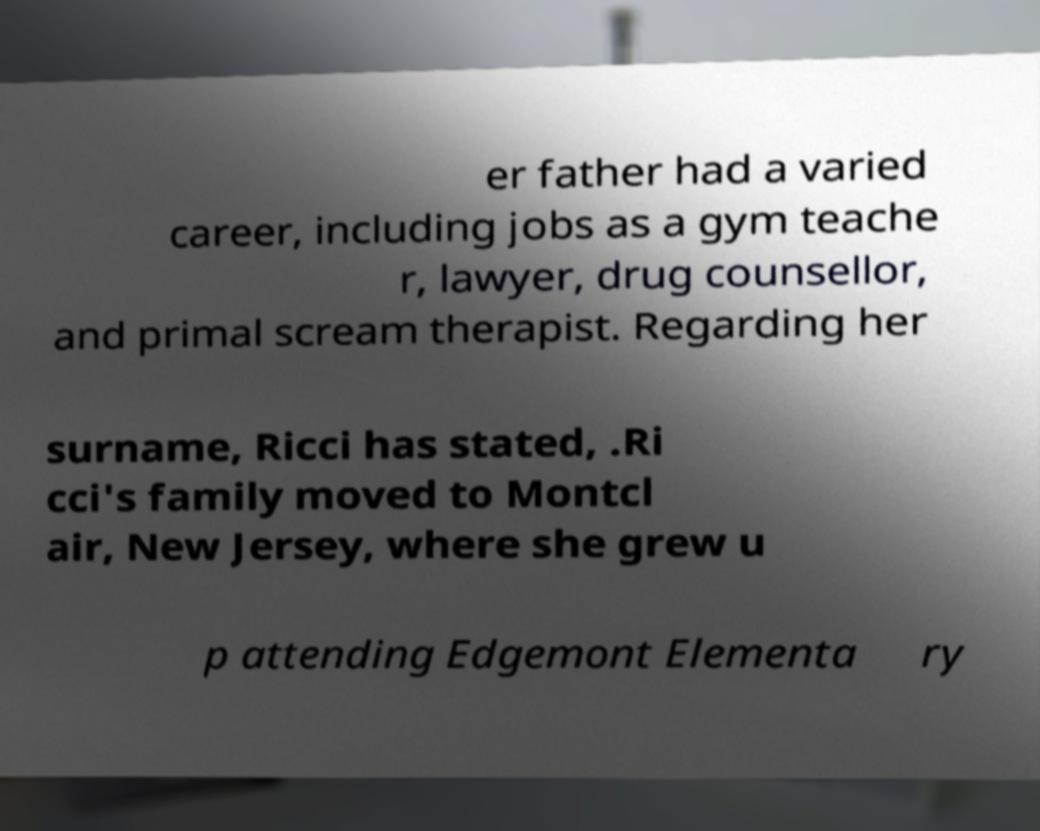I need the written content from this picture converted into text. Can you do that? er father had a varied career, including jobs as a gym teache r, lawyer, drug counsellor, and primal scream therapist. Regarding her surname, Ricci has stated, .Ri cci's family moved to Montcl air, New Jersey, where she grew u p attending Edgemont Elementa ry 